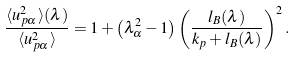<formula> <loc_0><loc_0><loc_500><loc_500>\frac { \langle u _ { p \alpha } ^ { 2 } \rangle ( \lambda ) } { \langle u _ { p \alpha } ^ { 2 } \rangle } = 1 + \left ( \lambda _ { \alpha } ^ { 2 } - 1 \right ) \left ( \frac { l _ { B } ( \lambda ) } { k _ { p } + l _ { B } ( \lambda ) } \right ) ^ { 2 } .</formula> 